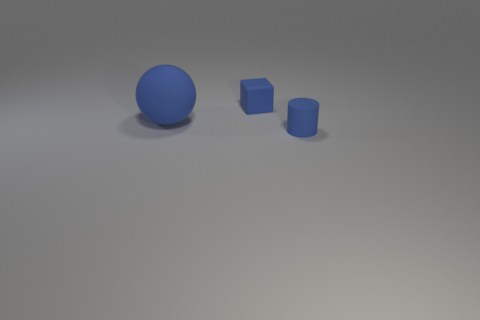Is there anything else that has the same shape as the large blue matte thing?
Give a very brief answer. No. There is a small thing that is the same color as the tiny rubber cube; what shape is it?
Provide a short and direct response. Cylinder. Is the number of big spheres that are on the left side of the matte ball the same as the number of blue cylinders?
Your response must be concise. No. There is a small thing that is in front of the large object; is there a blue object that is to the left of it?
Offer a very short reply. Yes. Is there any other thing of the same color as the big rubber sphere?
Your answer should be compact. Yes. Are there an equal number of big blue rubber balls that are in front of the small matte cylinder and tiny cubes in front of the small block?
Offer a very short reply. Yes. There is a object that is on the left side of the tiny thing on the left side of the cylinder; how big is it?
Make the answer very short. Large. What number of other things are the same size as the blue matte ball?
Your answer should be very brief. 0. The tiny rubber cube has what color?
Ensure brevity in your answer.  Blue. Does the small matte object that is on the left side of the small blue cylinder have the same color as the tiny thing in front of the big matte thing?
Offer a very short reply. Yes. 